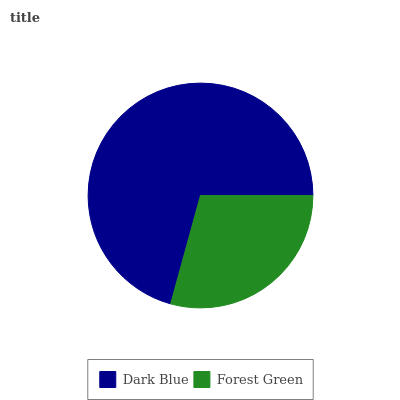Is Forest Green the minimum?
Answer yes or no. Yes. Is Dark Blue the maximum?
Answer yes or no. Yes. Is Forest Green the maximum?
Answer yes or no. No. Is Dark Blue greater than Forest Green?
Answer yes or no. Yes. Is Forest Green less than Dark Blue?
Answer yes or no. Yes. Is Forest Green greater than Dark Blue?
Answer yes or no. No. Is Dark Blue less than Forest Green?
Answer yes or no. No. Is Dark Blue the high median?
Answer yes or no. Yes. Is Forest Green the low median?
Answer yes or no. Yes. Is Forest Green the high median?
Answer yes or no. No. Is Dark Blue the low median?
Answer yes or no. No. 